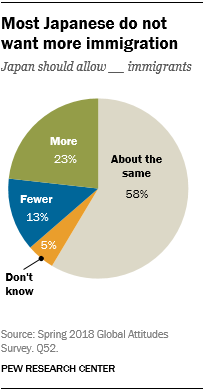Outline some significant characteristics in this image. In response to the prompt 'What color represents 'Don't know?' the individual stated that orange represents that option. 